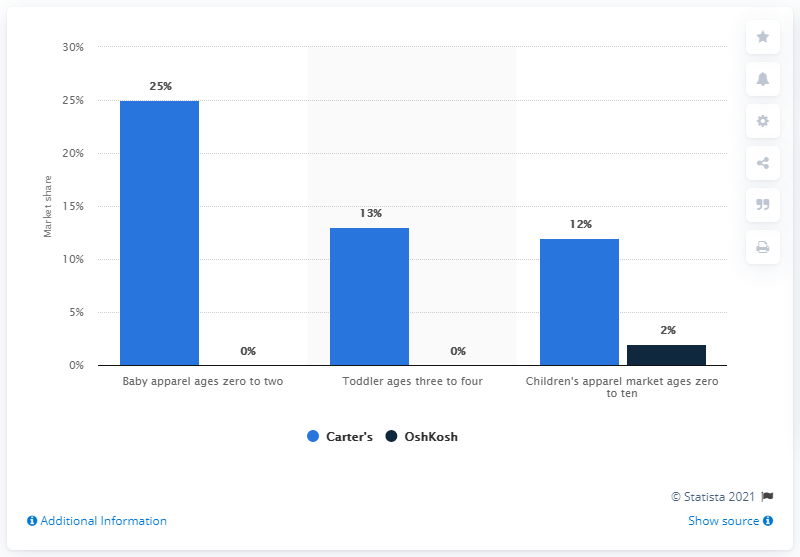Indicate a few pertinent items in this graphic. The result of adding Carter's percentage in the toddler ages three to four and the children's apparel market ages zero to ten, subtracting it from Carter's baby apparel ages zero to two, is zero. The value of the tallest blue bar is 25. 